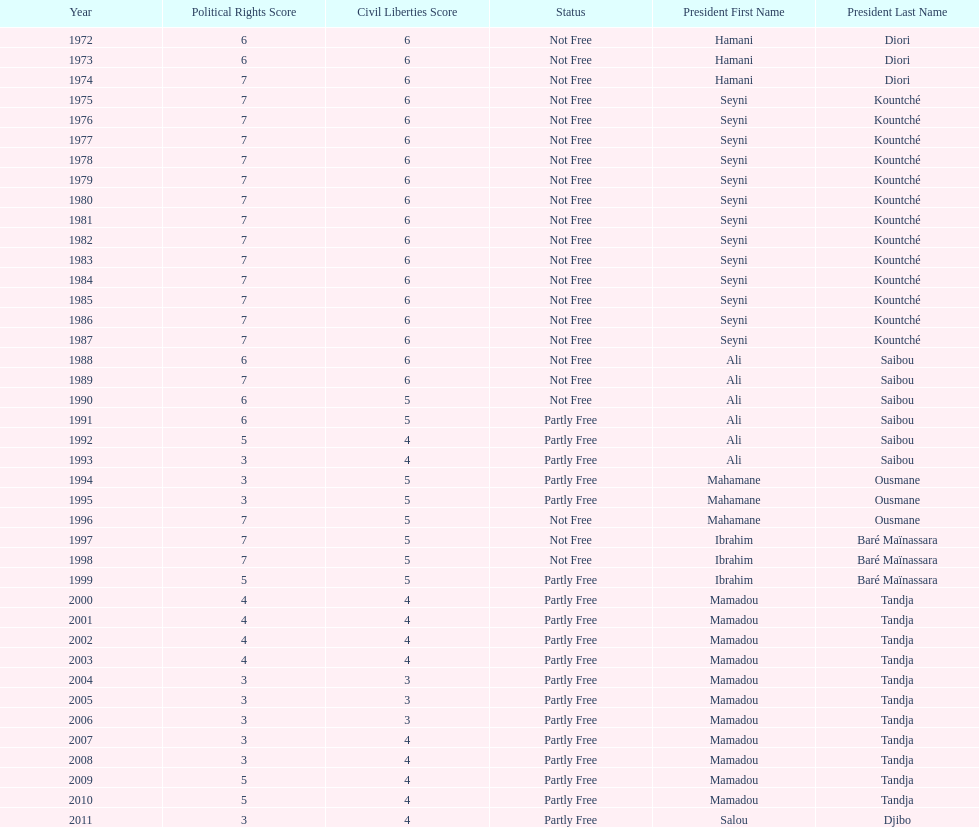Who is the next president listed after hamani diori in the year 1974? Seyni Kountché. 